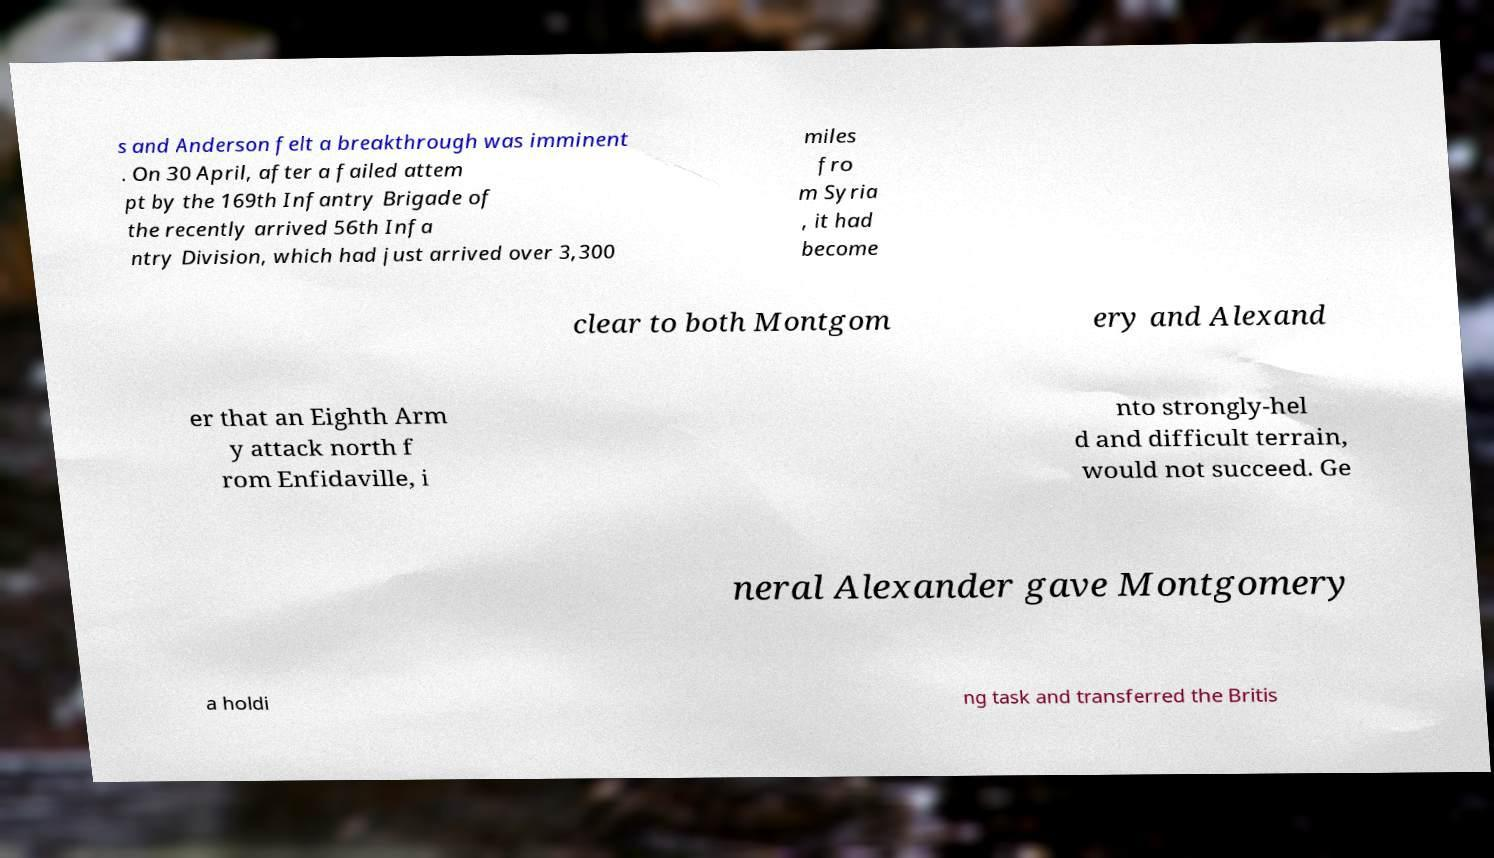What messages or text are displayed in this image? I need them in a readable, typed format. s and Anderson felt a breakthrough was imminent . On 30 April, after a failed attem pt by the 169th Infantry Brigade of the recently arrived 56th Infa ntry Division, which had just arrived over 3,300 miles fro m Syria , it had become clear to both Montgom ery and Alexand er that an Eighth Arm y attack north f rom Enfidaville, i nto strongly-hel d and difficult terrain, would not succeed. Ge neral Alexander gave Montgomery a holdi ng task and transferred the Britis 